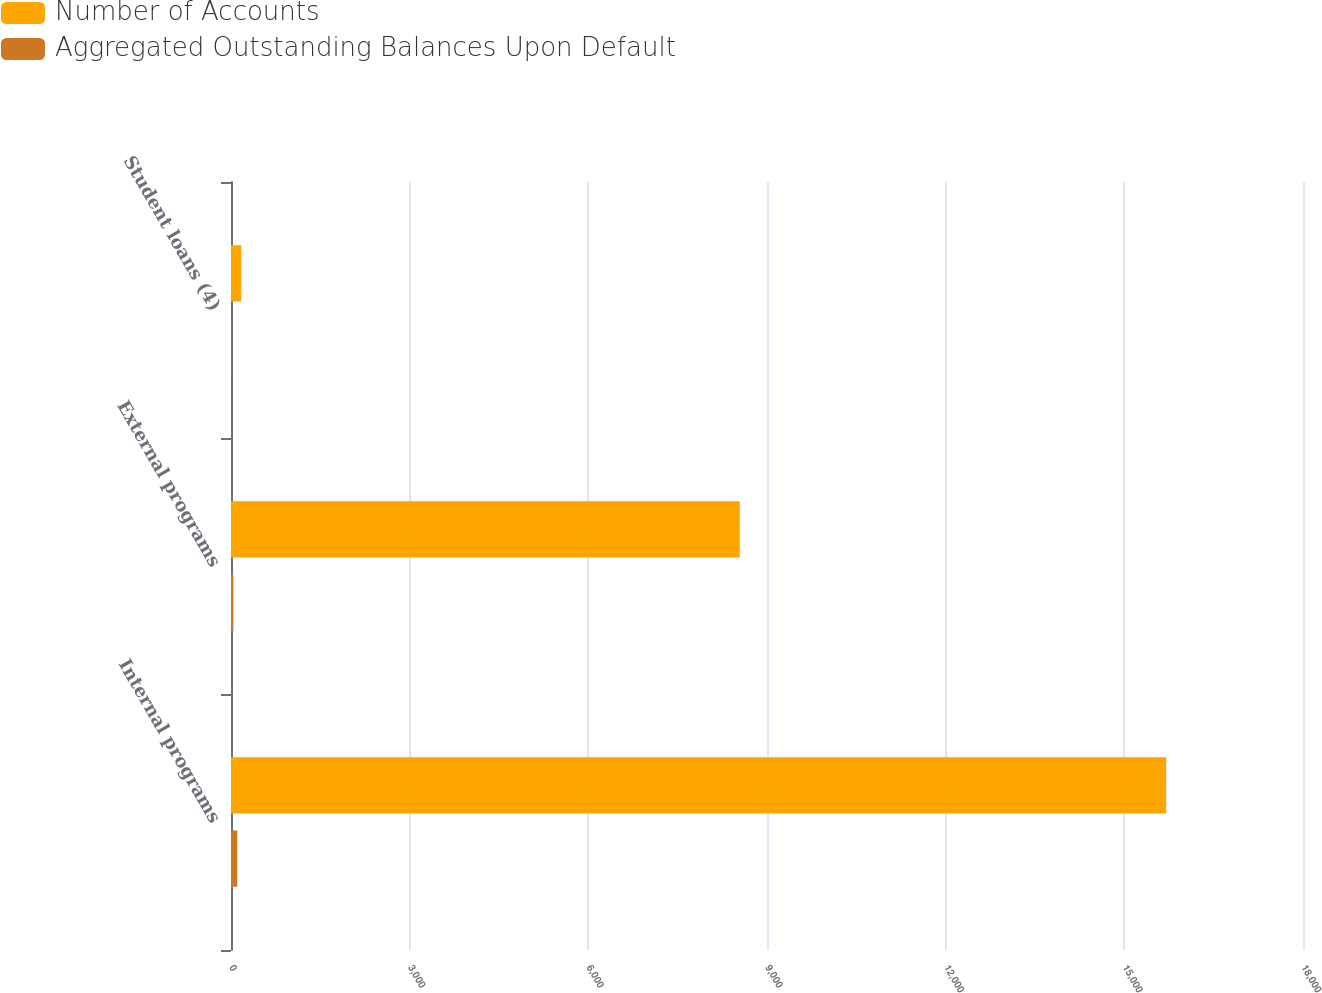Convert chart. <chart><loc_0><loc_0><loc_500><loc_500><stacked_bar_chart><ecel><fcel>Internal programs<fcel>External programs<fcel>Student loans (4)<nl><fcel>Number of Accounts<fcel>15703<fcel>8543<fcel>172<nl><fcel>Aggregated Outstanding Balances Upon Default<fcel>106<fcel>40<fcel>4<nl></chart> 